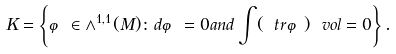<formula> <loc_0><loc_0><loc_500><loc_500>K = \left \{ \varphi \in { \wedge ^ { 1 , 1 } } ( M ) \colon d \varphi = 0 a n d \int ( \ t r \varphi ) \ v o l = 0 \right \} .</formula> 